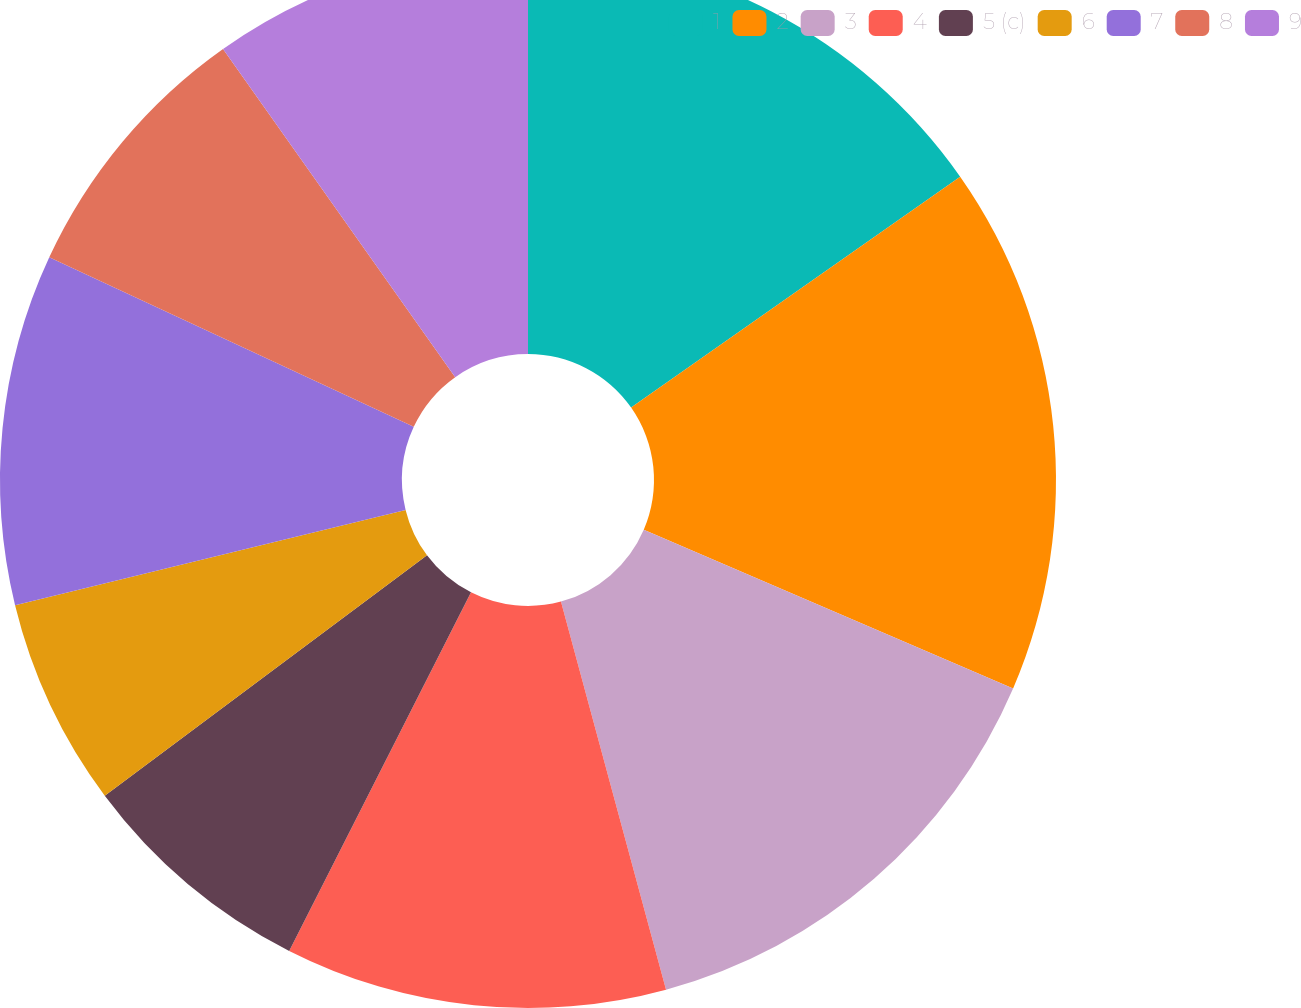Convert chart. <chart><loc_0><loc_0><loc_500><loc_500><pie_chart><fcel>1<fcel>2<fcel>3<fcel>4<fcel>5 (c)<fcel>6<fcel>7<fcel>8<fcel>9<nl><fcel>15.26%<fcel>16.2%<fcel>14.33%<fcel>11.68%<fcel>7.33%<fcel>6.39%<fcel>10.74%<fcel>8.27%<fcel>9.8%<nl></chart> 